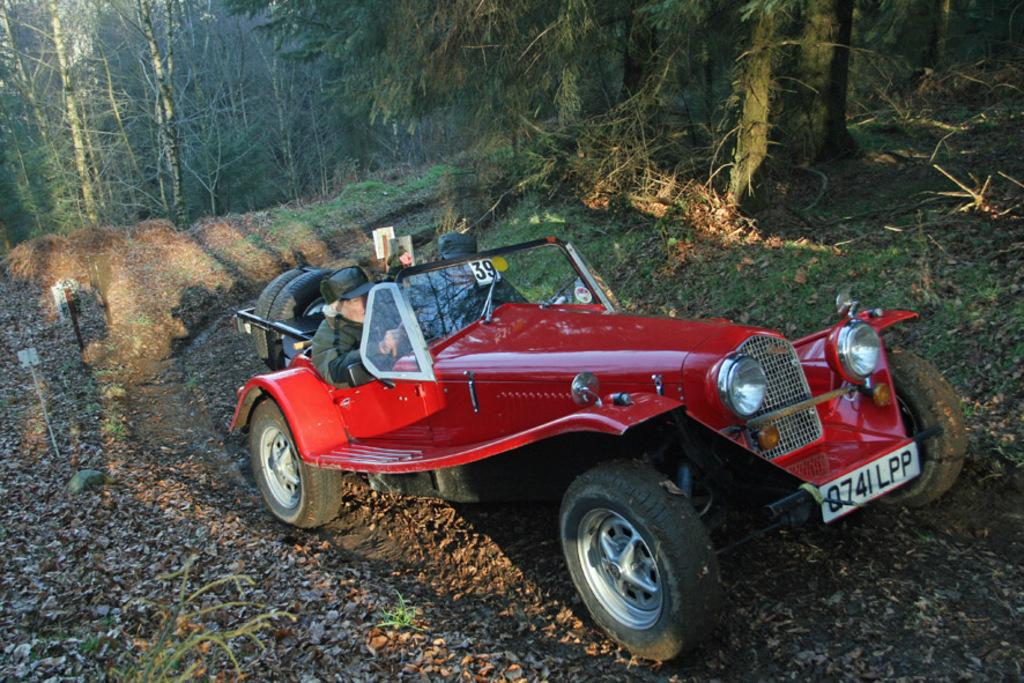What is the main subject of the image? There is a vehicle in the image. Who is inside the vehicle? There are two persons in the vehicle. What are the persons wearing? The persons are wearing caps. What is the ground surface like in the image? There is grass on the ground in the image. What can be seen in the background of the image? There are trees visible in the background of the image. What type of drug can be seen in the image? There is no drug present in the image. How many toes are visible in the image? There are no visible toes in the image. 